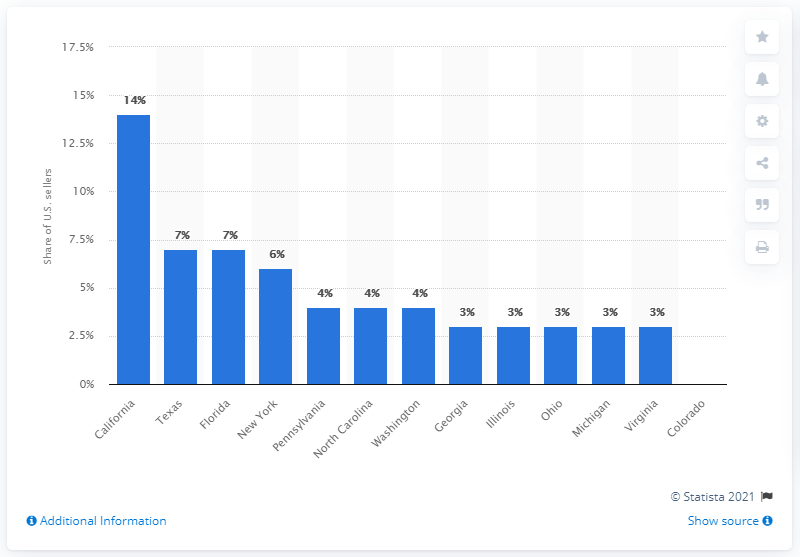Outline some significant characteristics in this image. California had the largest proportion of Etsy sellers among all states. 